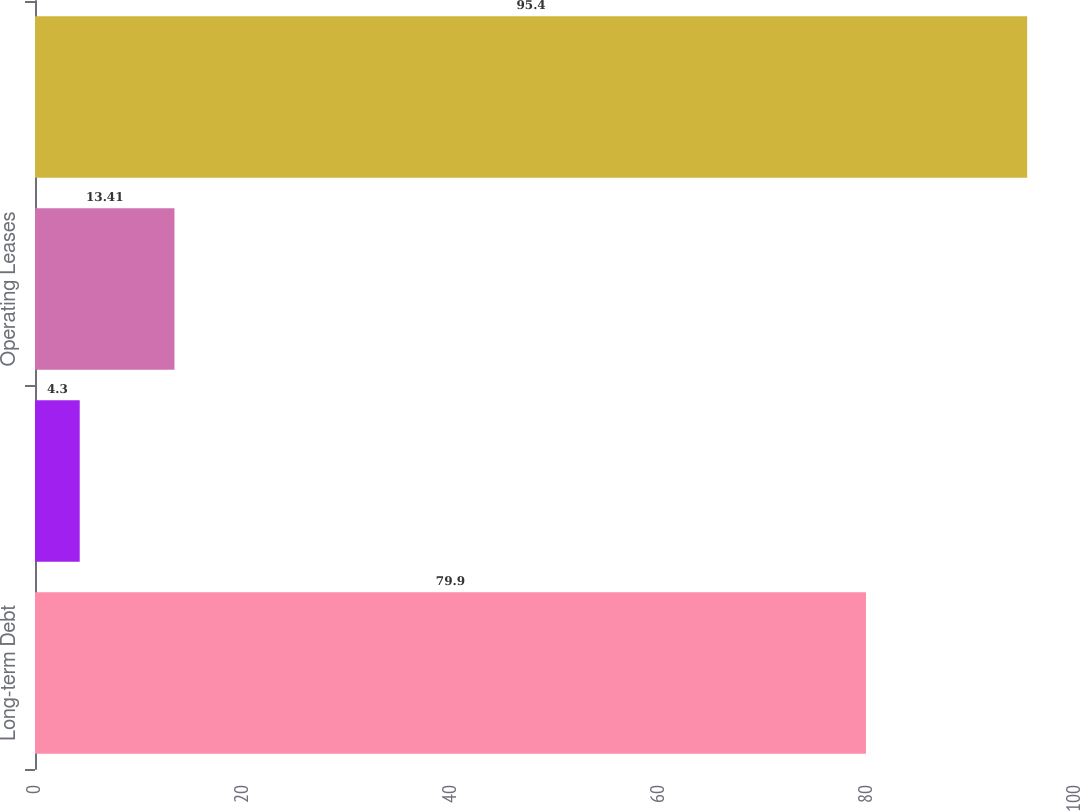Convert chart. <chart><loc_0><loc_0><loc_500><loc_500><bar_chart><fcel>Long-term Debt<fcel>Fixed Rate Interest<fcel>Operating Leases<fcel>Total<nl><fcel>79.9<fcel>4.3<fcel>13.41<fcel>95.4<nl></chart> 